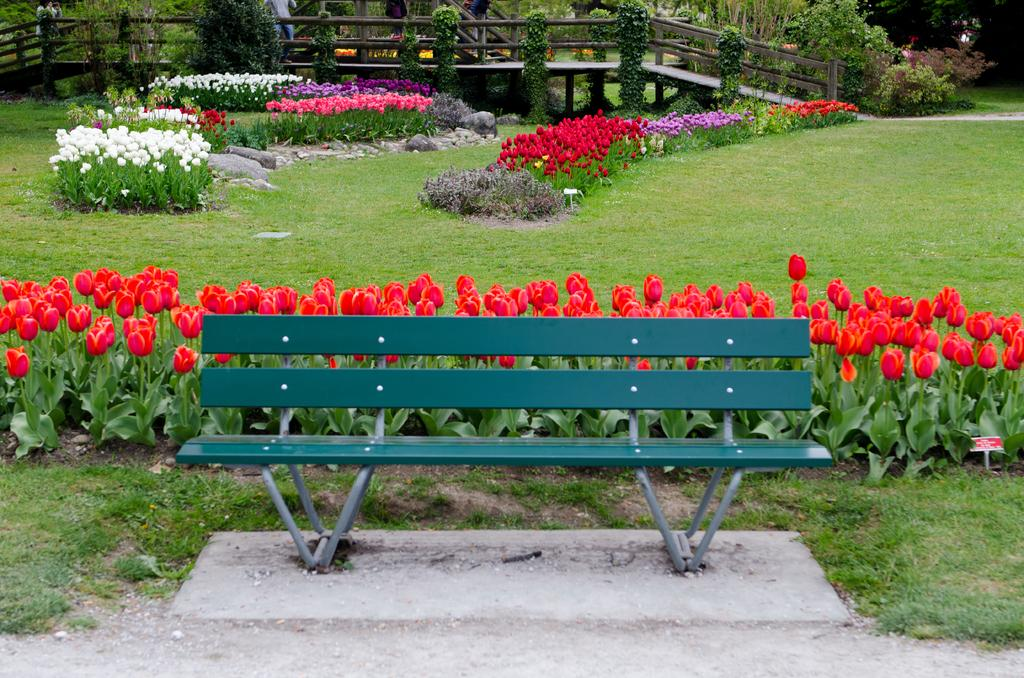What type of seating is visible in the image? There is a bench in the image. What type of vegetation can be seen in the image? There are plants, flowers, grass, and trees visible in the image. What other objects are present in the image? There are rocks in the image. Can you describe the background of the image? In the background of the image, there are people, railing, and trees. Is there a volcano visible in the image? No, there is no volcano present in the image. What type of land is depicted in the image? The image does not specifically depict a type of land; it features a bench, plants, flowers, grass, rocks, and a background with people, railing, and trees. 